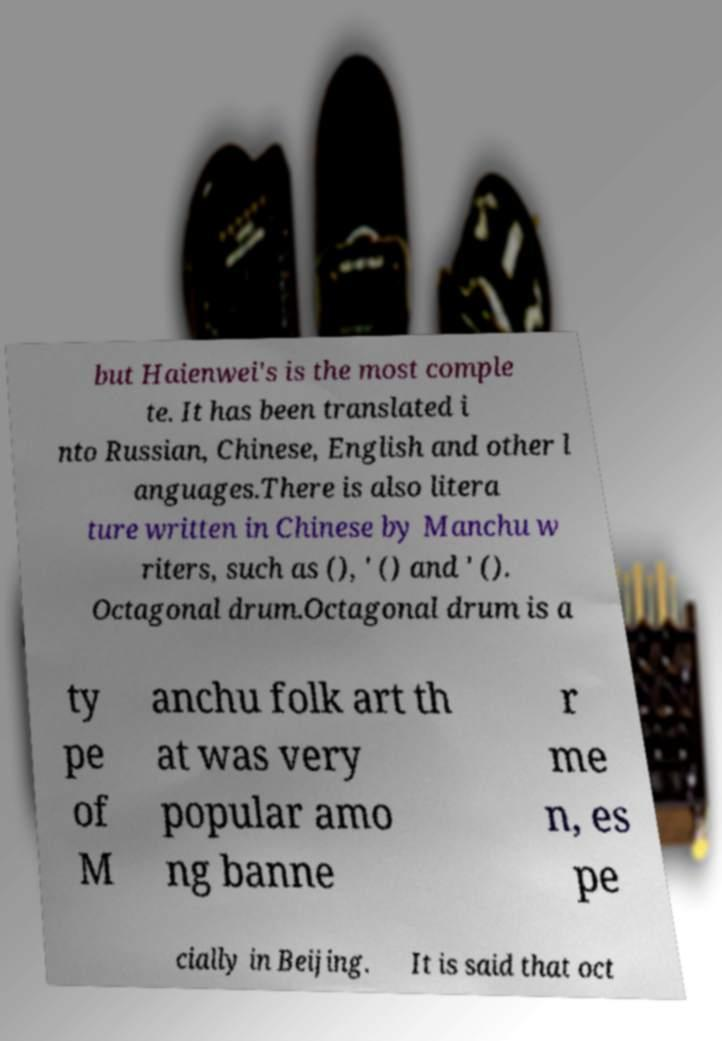Can you accurately transcribe the text from the provided image for me? but Haienwei's is the most comple te. It has been translated i nto Russian, Chinese, English and other l anguages.There is also litera ture written in Chinese by Manchu w riters, such as (), ' () and ' (). Octagonal drum.Octagonal drum is a ty pe of M anchu folk art th at was very popular amo ng banne r me n, es pe cially in Beijing. It is said that oct 